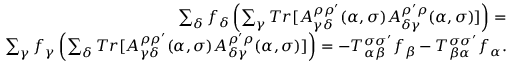Convert formula to latex. <formula><loc_0><loc_0><loc_500><loc_500>\begin{array} { r } { \sum _ { \delta } f _ { \delta } \left ( \sum _ { \gamma } T r [ A _ { \gamma \delta } ^ { \rho \rho ^ { \prime } } ( \alpha , \sigma ) A _ { \delta \gamma } ^ { \rho ^ { \prime } \rho } ( \alpha , \sigma ) ] \right ) = } \\ { \sum _ { \gamma } f _ { \gamma } \left ( \sum _ { \delta } T r [ A _ { \gamma \delta } ^ { \rho \rho ^ { \prime } } ( \alpha , \sigma ) A _ { \delta \gamma } ^ { \rho ^ { \prime } \rho } ( \alpha , \sigma ) ] \right ) = - T _ { \alpha \beta } ^ { \sigma \sigma ^ { \prime } } f _ { \beta } - T _ { \beta \alpha } ^ { \sigma \sigma ^ { \prime } } f _ { \alpha } . } \end{array}</formula> 